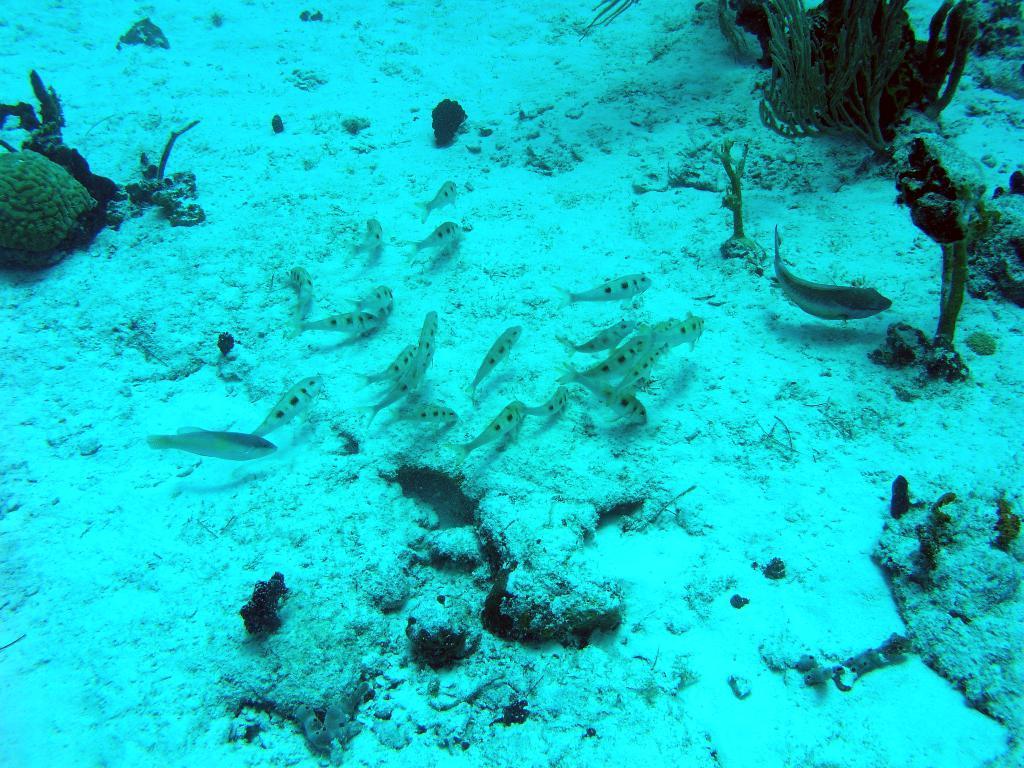Could you give a brief overview of what you see in this image? Here in this picture we can see under water picture, in which we can see fishes present and we can see some stones present on the ground and we can also see plants present. 